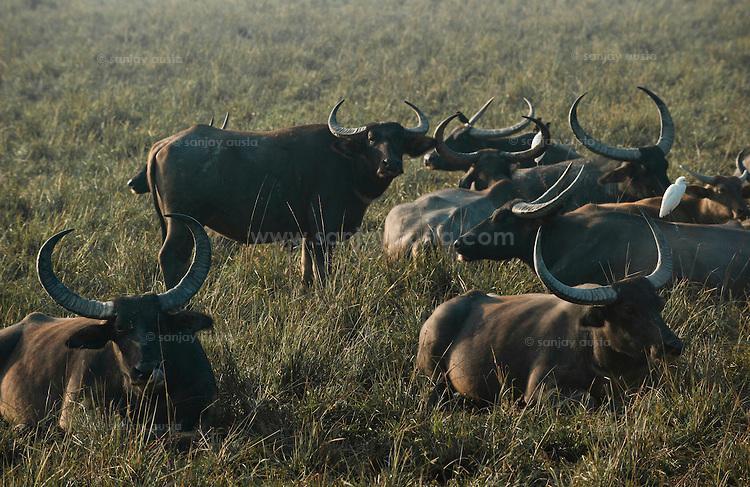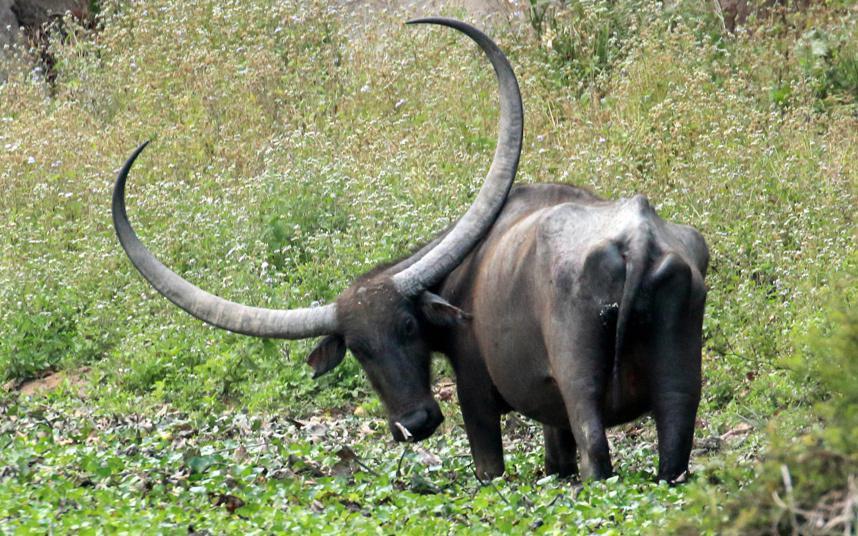The first image is the image on the left, the second image is the image on the right. Examine the images to the left and right. Is the description "There are more animals in the image on the right than in the image on the left." accurate? Answer yes or no. No. The first image is the image on the left, the second image is the image on the right. Considering the images on both sides, is "Left image shows one water buffalo standing in profile, with body turned leftward." valid? Answer yes or no. No. 